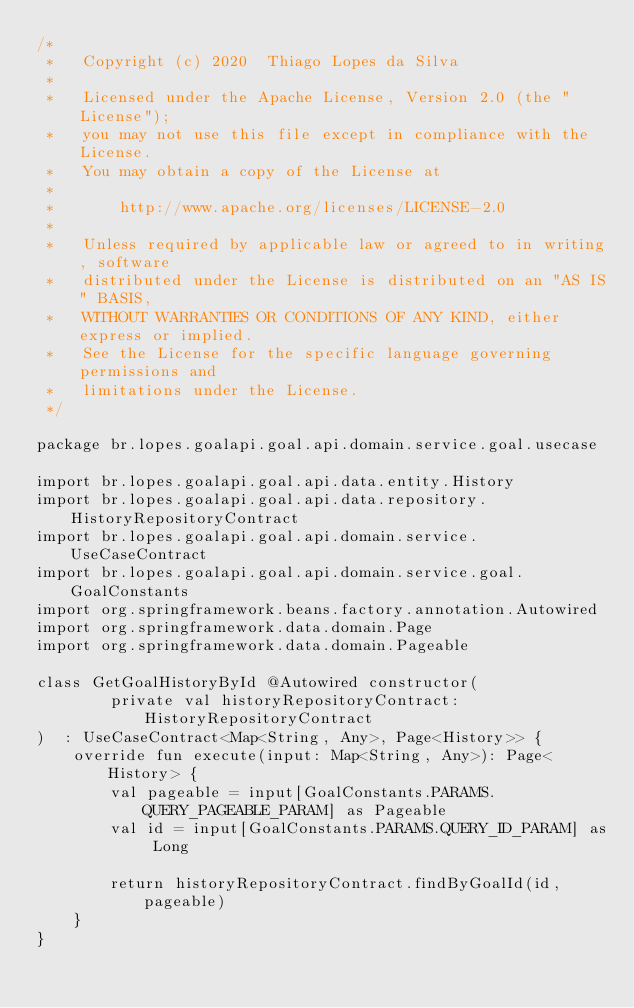Convert code to text. <code><loc_0><loc_0><loc_500><loc_500><_Kotlin_>/*
 *   Copyright (c) 2020  Thiago Lopes da Silva
 *
 *   Licensed under the Apache License, Version 2.0 (the "License");
 *   you may not use this file except in compliance with the License.
 *   You may obtain a copy of the License at
 *
 *       http://www.apache.org/licenses/LICENSE-2.0
 *
 *   Unless required by applicable law or agreed to in writing, software
 *   distributed under the License is distributed on an "AS IS" BASIS,
 *   WITHOUT WARRANTIES OR CONDITIONS OF ANY KIND, either express or implied.
 *   See the License for the specific language governing permissions and
 *   limitations under the License.
 */

package br.lopes.goalapi.goal.api.domain.service.goal.usecase

import br.lopes.goalapi.goal.api.data.entity.History
import br.lopes.goalapi.goal.api.data.repository.HistoryRepositoryContract
import br.lopes.goalapi.goal.api.domain.service.UseCaseContract
import br.lopes.goalapi.goal.api.domain.service.goal.GoalConstants
import org.springframework.beans.factory.annotation.Autowired
import org.springframework.data.domain.Page
import org.springframework.data.domain.Pageable

class GetGoalHistoryById @Autowired constructor(
        private val historyRepositoryContract: HistoryRepositoryContract
)  : UseCaseContract<Map<String, Any>, Page<History>> {
    override fun execute(input: Map<String, Any>): Page<History> {
        val pageable = input[GoalConstants.PARAMS.QUERY_PAGEABLE_PARAM] as Pageable
        val id = input[GoalConstants.PARAMS.QUERY_ID_PARAM] as Long

        return historyRepositoryContract.findByGoalId(id, pageable)
    }
}</code> 